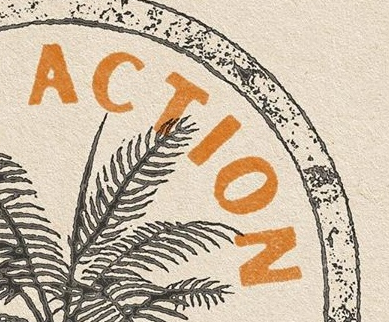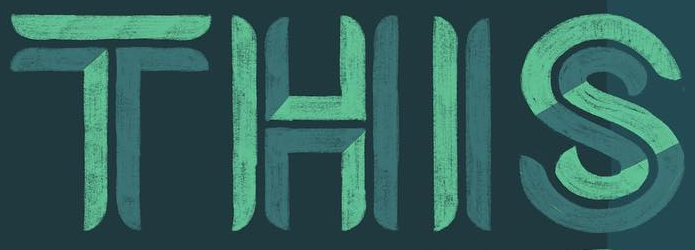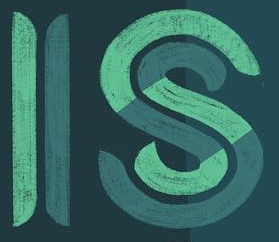What text appears in these images from left to right, separated by a semicolon? ACTION; THIS; IS 